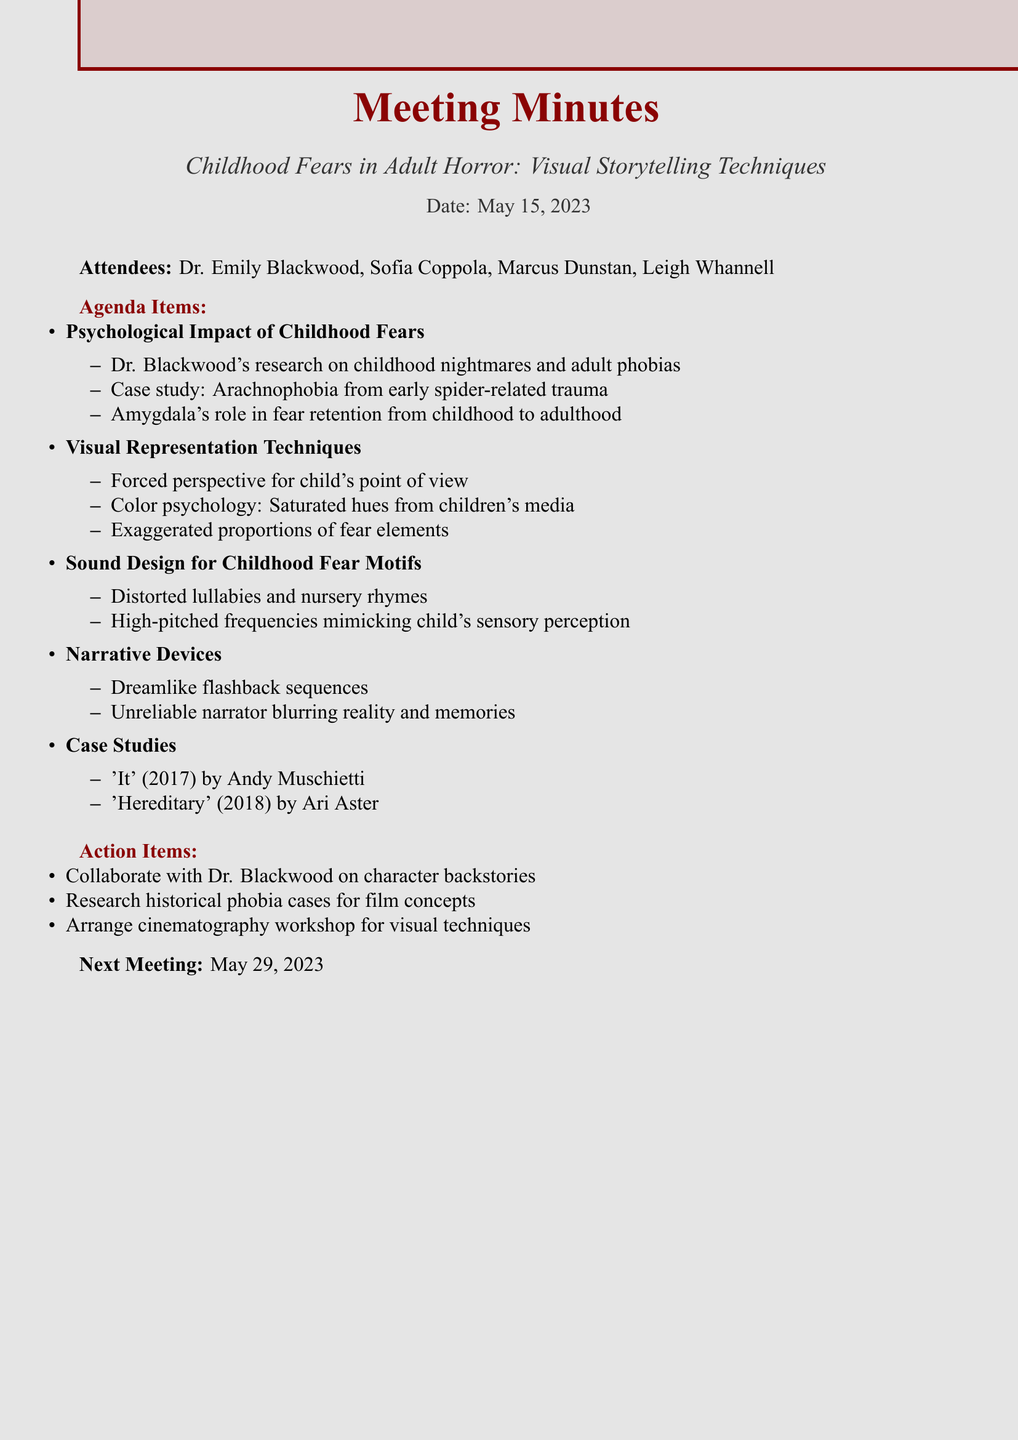What is the date of the meeting? The date of the meeting is specified in the document as May 15, 2023.
Answer: May 15, 2023 Who attended the meeting as the psychologist? The document lists attendees, identifying Dr. Emily Blackwood as the psychologist.
Answer: Dr. Emily Blackwood What is the first agenda item discussed? The document outlines the agenda items, with the first one being about the psychological impact of childhood fears.
Answer: Psychological Impact of Childhood Fears What is one visual representation technique mentioned? The document includes a section on visual representation techniques, stating that forced perspective can emulate a child's point of view.
Answer: Forced perspective When is the next meeting scheduled? The document states that the next meeting is on May 29, 2023.
Answer: May 29, 2023 What is one action item from the meeting? The action items include collaborating with Dr. Blackwood on character backstories rooted in childhood trauma.
Answer: Collaborate with Dr. Blackwood on character backstories What case study was mentioned related to arachnophobia? The document mentions a case study related to arachnophobia stemming from early exposure to spider-related trauma.
Answer: Arachnophobia stemming from early exposure to spider-related trauma What sound design element is suggested for childhood fear motifs? The document proposes incorporating distorted lullabies or nursery rhymes in sound design for childhood fear motifs.
Answer: Distorted lullabies or nursery rhymes 